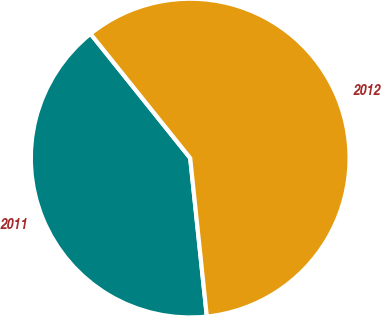Convert chart. <chart><loc_0><loc_0><loc_500><loc_500><pie_chart><fcel>2011<fcel>2012<nl><fcel>40.91%<fcel>59.09%<nl></chart> 